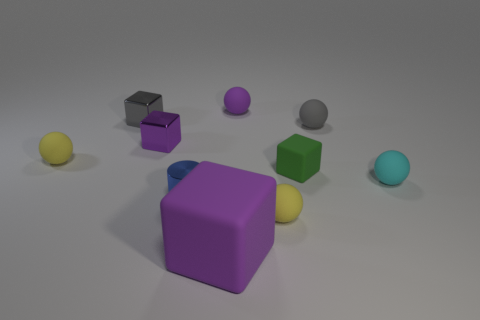Subtract 2 cubes. How many cubes are left? 2 Subtract all purple balls. How many balls are left? 4 Subtract all gray balls. How many balls are left? 4 Subtract all red blocks. Subtract all cyan cylinders. How many blocks are left? 4 Subtract all cubes. How many objects are left? 6 Subtract 1 green cubes. How many objects are left? 9 Subtract all small gray blocks. Subtract all cyan matte balls. How many objects are left? 8 Add 2 small blue shiny cylinders. How many small blue shiny cylinders are left? 3 Add 7 small yellow metallic cylinders. How many small yellow metallic cylinders exist? 7 